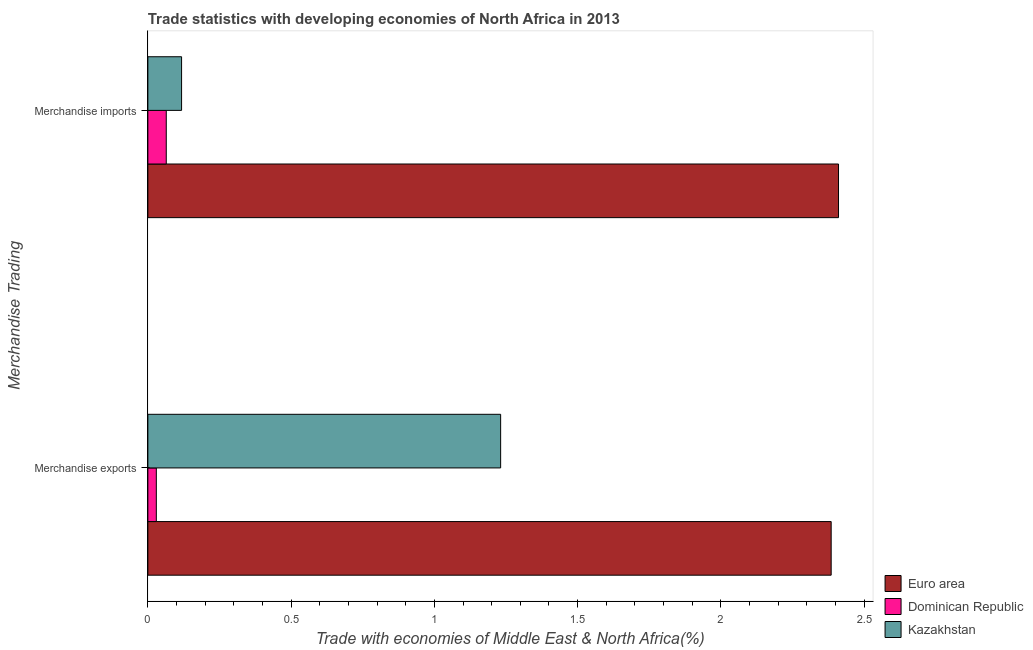How many groups of bars are there?
Provide a short and direct response. 2. Are the number of bars per tick equal to the number of legend labels?
Your answer should be very brief. Yes. Are the number of bars on each tick of the Y-axis equal?
Your response must be concise. Yes. How many bars are there on the 1st tick from the bottom?
Provide a succinct answer. 3. What is the merchandise imports in Euro area?
Ensure brevity in your answer.  2.41. Across all countries, what is the maximum merchandise imports?
Keep it short and to the point. 2.41. Across all countries, what is the minimum merchandise exports?
Your answer should be very brief. 0.03. In which country was the merchandise imports maximum?
Offer a very short reply. Euro area. In which country was the merchandise imports minimum?
Make the answer very short. Dominican Republic. What is the total merchandise exports in the graph?
Your answer should be compact. 3.65. What is the difference between the merchandise imports in Euro area and that in Dominican Republic?
Your answer should be very brief. 2.35. What is the difference between the merchandise imports in Dominican Republic and the merchandise exports in Kazakhstan?
Keep it short and to the point. -1.17. What is the average merchandise imports per country?
Offer a very short reply. 0.86. What is the difference between the merchandise imports and merchandise exports in Dominican Republic?
Offer a very short reply. 0.03. In how many countries, is the merchandise exports greater than 0.5 %?
Provide a succinct answer. 2. What is the ratio of the merchandise exports in Dominican Republic to that in Euro area?
Your answer should be very brief. 0.01. Is the merchandise exports in Kazakhstan less than that in Dominican Republic?
Give a very brief answer. No. How many bars are there?
Provide a succinct answer. 6. Are all the bars in the graph horizontal?
Ensure brevity in your answer.  Yes. What is the difference between two consecutive major ticks on the X-axis?
Ensure brevity in your answer.  0.5. Does the graph contain grids?
Give a very brief answer. No. How many legend labels are there?
Make the answer very short. 3. What is the title of the graph?
Offer a very short reply. Trade statistics with developing economies of North Africa in 2013. What is the label or title of the X-axis?
Your response must be concise. Trade with economies of Middle East & North Africa(%). What is the label or title of the Y-axis?
Ensure brevity in your answer.  Merchandise Trading. What is the Trade with economies of Middle East & North Africa(%) of Euro area in Merchandise exports?
Make the answer very short. 2.38. What is the Trade with economies of Middle East & North Africa(%) in Dominican Republic in Merchandise exports?
Make the answer very short. 0.03. What is the Trade with economies of Middle East & North Africa(%) in Kazakhstan in Merchandise exports?
Your answer should be compact. 1.23. What is the Trade with economies of Middle East & North Africa(%) of Euro area in Merchandise imports?
Ensure brevity in your answer.  2.41. What is the Trade with economies of Middle East & North Africa(%) in Dominican Republic in Merchandise imports?
Your answer should be very brief. 0.06. What is the Trade with economies of Middle East & North Africa(%) in Kazakhstan in Merchandise imports?
Ensure brevity in your answer.  0.12. Across all Merchandise Trading, what is the maximum Trade with economies of Middle East & North Africa(%) of Euro area?
Provide a short and direct response. 2.41. Across all Merchandise Trading, what is the maximum Trade with economies of Middle East & North Africa(%) of Dominican Republic?
Provide a short and direct response. 0.06. Across all Merchandise Trading, what is the maximum Trade with economies of Middle East & North Africa(%) of Kazakhstan?
Offer a terse response. 1.23. Across all Merchandise Trading, what is the minimum Trade with economies of Middle East & North Africa(%) of Euro area?
Your response must be concise. 2.38. Across all Merchandise Trading, what is the minimum Trade with economies of Middle East & North Africa(%) in Dominican Republic?
Keep it short and to the point. 0.03. Across all Merchandise Trading, what is the minimum Trade with economies of Middle East & North Africa(%) in Kazakhstan?
Ensure brevity in your answer.  0.12. What is the total Trade with economies of Middle East & North Africa(%) of Euro area in the graph?
Offer a terse response. 4.8. What is the total Trade with economies of Middle East & North Africa(%) in Dominican Republic in the graph?
Provide a short and direct response. 0.09. What is the total Trade with economies of Middle East & North Africa(%) in Kazakhstan in the graph?
Offer a very short reply. 1.35. What is the difference between the Trade with economies of Middle East & North Africa(%) of Euro area in Merchandise exports and that in Merchandise imports?
Provide a succinct answer. -0.03. What is the difference between the Trade with economies of Middle East & North Africa(%) of Dominican Republic in Merchandise exports and that in Merchandise imports?
Your answer should be very brief. -0.03. What is the difference between the Trade with economies of Middle East & North Africa(%) of Kazakhstan in Merchandise exports and that in Merchandise imports?
Ensure brevity in your answer.  1.11. What is the difference between the Trade with economies of Middle East & North Africa(%) of Euro area in Merchandise exports and the Trade with economies of Middle East & North Africa(%) of Dominican Republic in Merchandise imports?
Keep it short and to the point. 2.32. What is the difference between the Trade with economies of Middle East & North Africa(%) in Euro area in Merchandise exports and the Trade with economies of Middle East & North Africa(%) in Kazakhstan in Merchandise imports?
Offer a terse response. 2.27. What is the difference between the Trade with economies of Middle East & North Africa(%) of Dominican Republic in Merchandise exports and the Trade with economies of Middle East & North Africa(%) of Kazakhstan in Merchandise imports?
Offer a terse response. -0.09. What is the average Trade with economies of Middle East & North Africa(%) in Euro area per Merchandise Trading?
Your answer should be very brief. 2.4. What is the average Trade with economies of Middle East & North Africa(%) in Dominican Republic per Merchandise Trading?
Provide a short and direct response. 0.05. What is the average Trade with economies of Middle East & North Africa(%) of Kazakhstan per Merchandise Trading?
Provide a short and direct response. 0.67. What is the difference between the Trade with economies of Middle East & North Africa(%) in Euro area and Trade with economies of Middle East & North Africa(%) in Dominican Republic in Merchandise exports?
Your answer should be compact. 2.36. What is the difference between the Trade with economies of Middle East & North Africa(%) of Euro area and Trade with economies of Middle East & North Africa(%) of Kazakhstan in Merchandise exports?
Give a very brief answer. 1.15. What is the difference between the Trade with economies of Middle East & North Africa(%) in Dominican Republic and Trade with economies of Middle East & North Africa(%) in Kazakhstan in Merchandise exports?
Your answer should be very brief. -1.2. What is the difference between the Trade with economies of Middle East & North Africa(%) in Euro area and Trade with economies of Middle East & North Africa(%) in Dominican Republic in Merchandise imports?
Provide a succinct answer. 2.35. What is the difference between the Trade with economies of Middle East & North Africa(%) in Euro area and Trade with economies of Middle East & North Africa(%) in Kazakhstan in Merchandise imports?
Make the answer very short. 2.29. What is the difference between the Trade with economies of Middle East & North Africa(%) of Dominican Republic and Trade with economies of Middle East & North Africa(%) of Kazakhstan in Merchandise imports?
Your answer should be compact. -0.05. What is the ratio of the Trade with economies of Middle East & North Africa(%) of Euro area in Merchandise exports to that in Merchandise imports?
Your answer should be compact. 0.99. What is the ratio of the Trade with economies of Middle East & North Africa(%) in Dominican Republic in Merchandise exports to that in Merchandise imports?
Ensure brevity in your answer.  0.46. What is the ratio of the Trade with economies of Middle East & North Africa(%) of Kazakhstan in Merchandise exports to that in Merchandise imports?
Give a very brief answer. 10.47. What is the difference between the highest and the second highest Trade with economies of Middle East & North Africa(%) of Euro area?
Your answer should be very brief. 0.03. What is the difference between the highest and the second highest Trade with economies of Middle East & North Africa(%) of Dominican Republic?
Your answer should be compact. 0.03. What is the difference between the highest and the second highest Trade with economies of Middle East & North Africa(%) in Kazakhstan?
Your answer should be very brief. 1.11. What is the difference between the highest and the lowest Trade with economies of Middle East & North Africa(%) of Euro area?
Your answer should be compact. 0.03. What is the difference between the highest and the lowest Trade with economies of Middle East & North Africa(%) of Dominican Republic?
Offer a terse response. 0.03. What is the difference between the highest and the lowest Trade with economies of Middle East & North Africa(%) in Kazakhstan?
Keep it short and to the point. 1.11. 